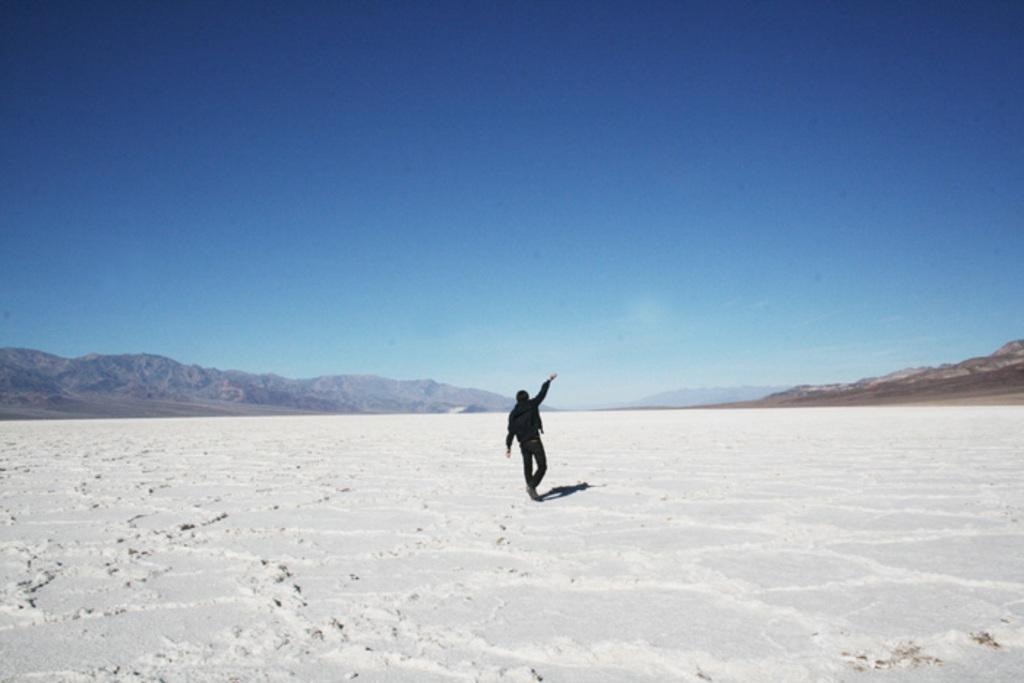What is the main subject of the image? There is a person standing in the image. What is the person wearing? The person is wearing a black dress. What type of landscape can be seen in the image? There are mountains visible in the image. What is the weather like in the image? There is snow in the image, indicating a cold climate. What is the color of the sky in the image? The sky is blue and white in color. What type of order or structure can be seen in the trail of the person in the image? There is no trail visible in the image, as the person is standing still. 